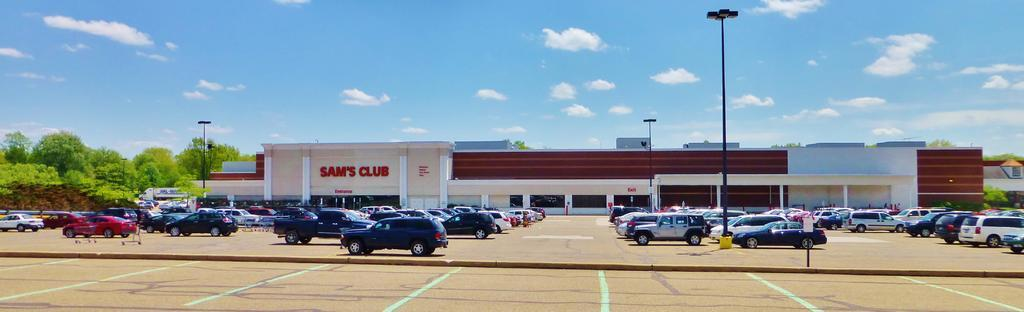What type of structures can be seen in the image? There are buildings in the image. What else can be seen moving in the image? There are vehicles and trolleys in the image. What are the vertical structures in the image? There are poles in the image. What type of vegetation is present in the image? There are trees in the image. What is visible beneath the structures and objects in the image? The ground is visible in the image. What is present on the ground in the image? There are objects on the ground. What is visible in the sky in the image? The sky is visible in the image, and there are clouds in the image. What type of dinner is being served in the image? There is no dinner present in the image; it features buildings, vehicles, poles, trees, ground, objects, trolleys, and clouds in the sky. What force is being applied to the buildings in the image? There is no force being applied to the buildings in the image; they are stationary structures. 